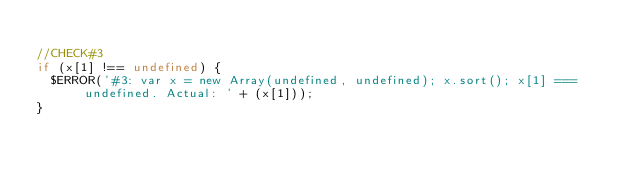<code> <loc_0><loc_0><loc_500><loc_500><_JavaScript_>
//CHECK#3
if (x[1] !== undefined) {
  $ERROR('#3: var x = new Array(undefined, undefined); x.sort(); x[1] === undefined. Actual: ' + (x[1]));
}  
</code> 